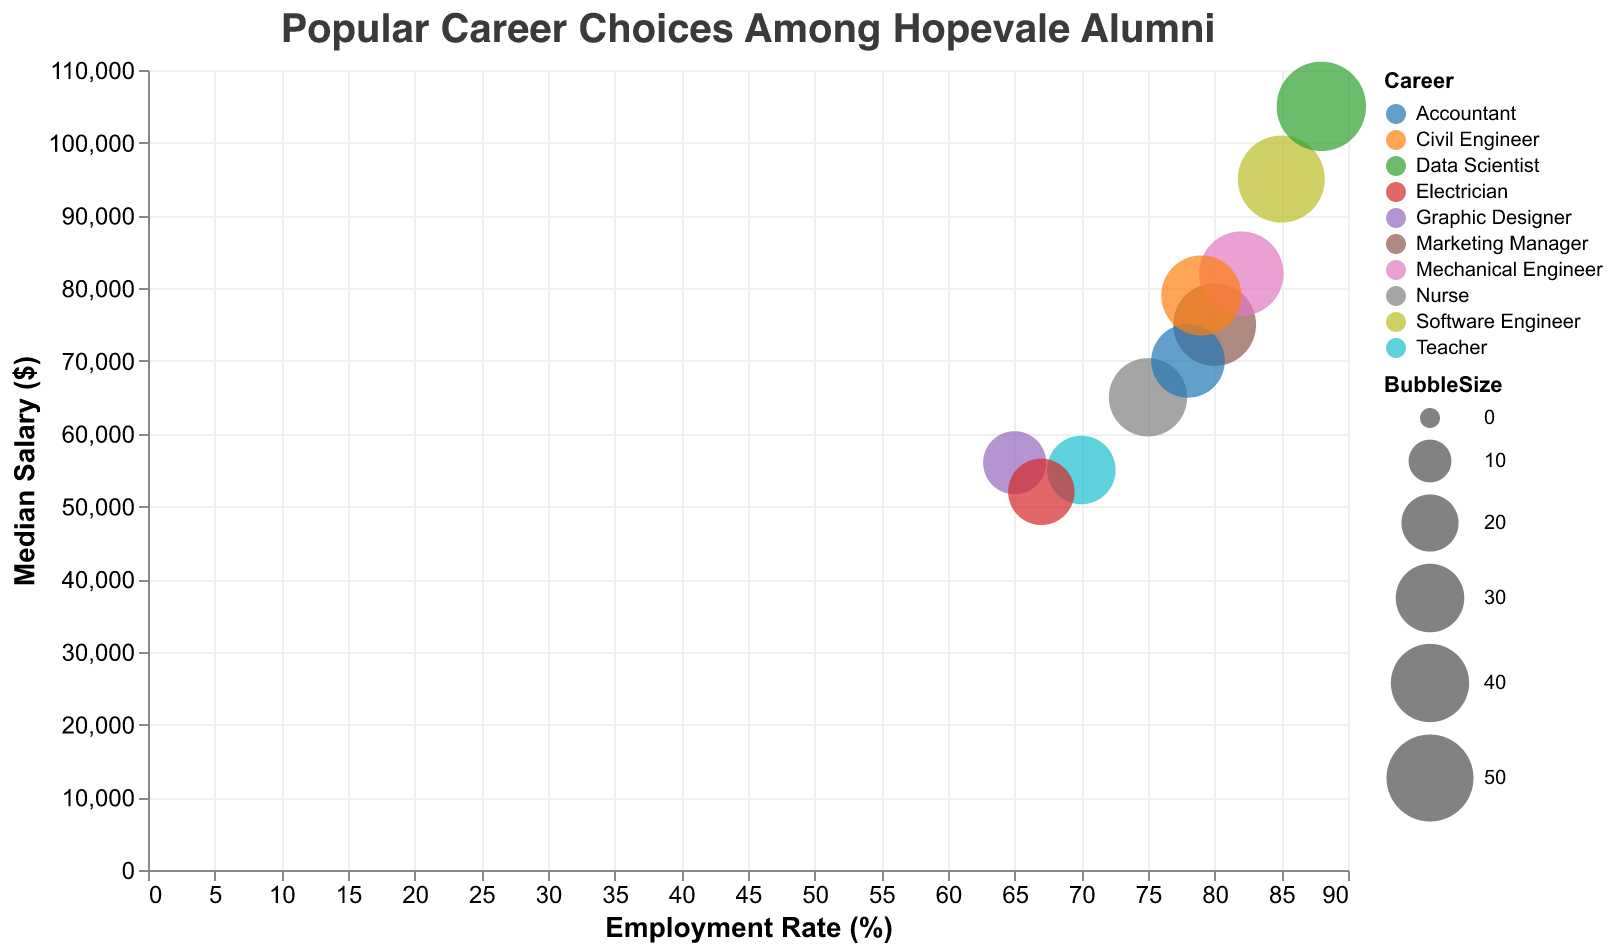What is the highest employment rate among the careers? The highest employment rate is depicted by the bubble that aligns furthest to the right on the x-axis, which is labeled "Data Scientist" with an employment rate of 88%.
Answer: 88% Which career has the lowest median salary? The lowest median salary is depicted by the bubble that aligns lowest on the y-axis, which is labeled "Electrician" with a median salary of $52,000.
Answer: Electrician What is the average median salary of the three careers with the highest employment rates? The three careers with the highest employment rates are Data Scientist (105,000), Software Engineer (95,000), and Mechanical Engineer (82,000). The average median salary is calculated as (105,000 + 95,000 + 82,000) / 3 = 282,000 / 3 = $94,000.
Answer: $94,000 What is the total bubble size for careers with an employment rate above 80%? The careers with an employment rate above 80% are Software Engineer (50), Mechanical Engineer (47), and Data Scientist (53). The total bubble size is 50 + 47 + 53 = 150.
Answer: 150 Which career has a higher median salary, Nurse or Accountant? Nurse has a median salary of $65,000 and Accountant has a median salary of $70,000. Comparing these values, Accountant has a higher median salary.
Answer: Accountant Which has a greater difference in employment rate relative to its median salary, Graphic Designer or Teacher? Graphic Designer has an employment rate of 65% with a median salary of $56,000, and Teacher has an employment rate of 70% with a median salary of $55,000. The difference for Graphic Designer is 65 - 56 = 9 and for Teacher it's 70 - 55 = 15. Teacher has a greater difference.
Answer: Teacher Which career has the largest bubble size on the chart? The largest bubble size corresponds to "Data Scientist," which has a bubble size of 53.
Answer: Data Scientist Which two careers are closest in terms of employment rate but differ significantly in median salary? "Accountant" (78%) and "Civil Engineer" (79%) have close employment rates, but their median salaries are $70,000 and $79,000, respectively, showing a significant difference in salary.
Answer: Accountant and Civil Engineer Which career with an employment rate below 70% has the highest median salary? The careers below 70% employment rate are Graphic Designer (65%) and Electrician (67%). Among these, "Graphic Designer" has the highest median salary of $56,000.
Answer: Graphic Designer 